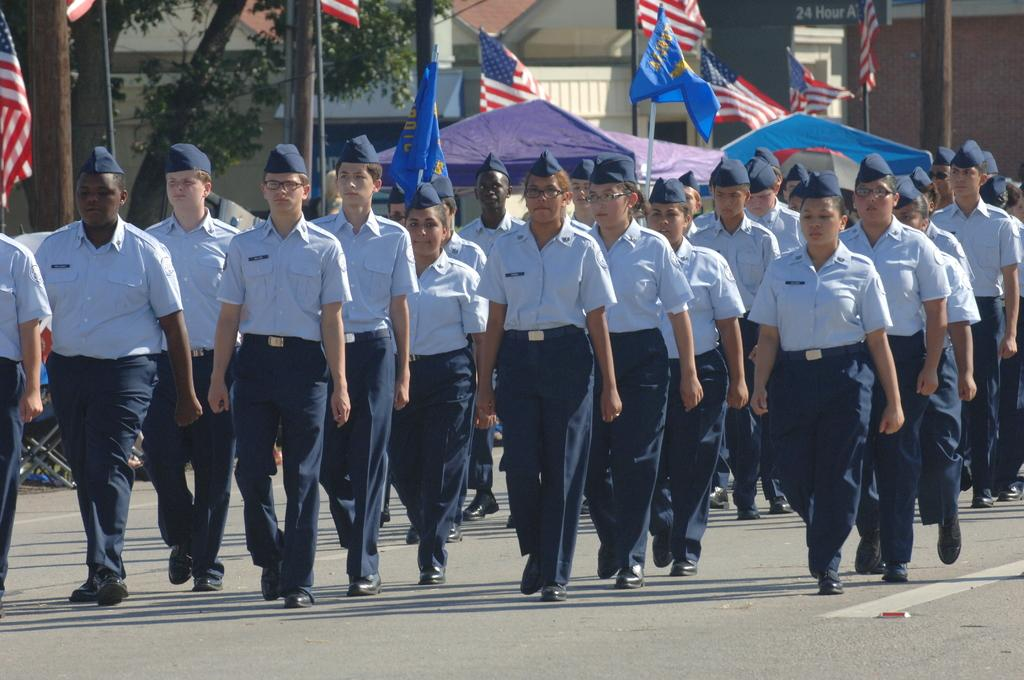What is happening in the image? There is a group of people standing in the image. What can be seen in the background of the image? There are flags with poles, a tent, a building, and trees in the background of the image. How many dogs are sitting on the curtain in the image? There are no dogs or curtains present in the image. 